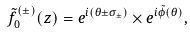<formula> <loc_0><loc_0><loc_500><loc_500>\tilde { f } _ { 0 } ^ { ( \pm ) } ( z ) = e ^ { i ( \theta \pm \sigma _ { \pm } ) } \times e ^ { i \tilde { \phi } ( \theta ) } ,</formula> 